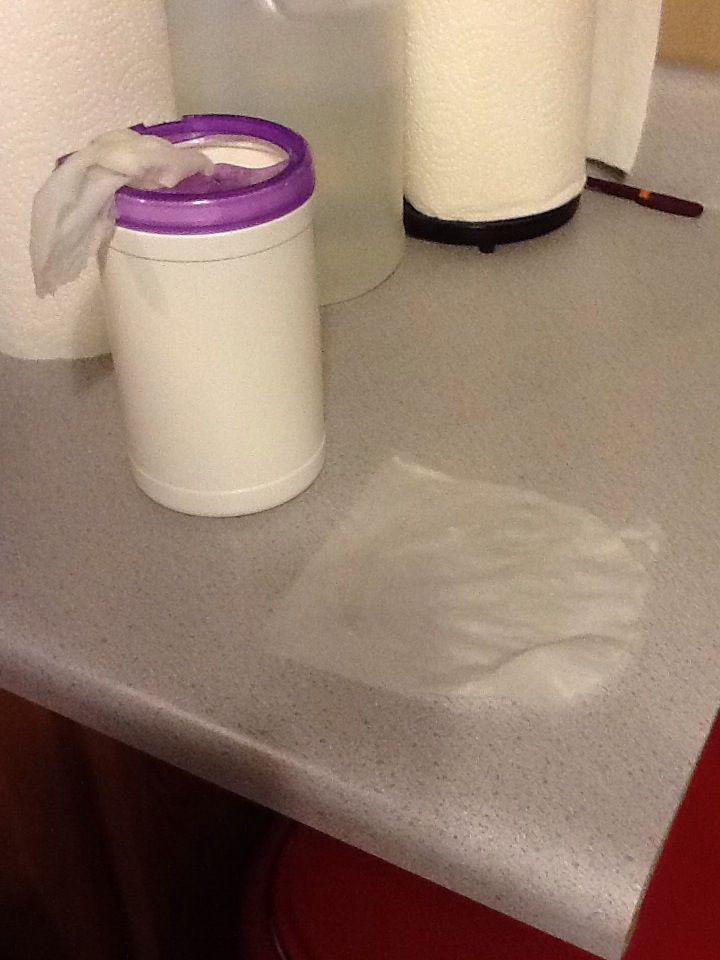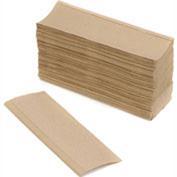The first image is the image on the left, the second image is the image on the right. Evaluate the accuracy of this statement regarding the images: "One of the images shows brown folded paper towels.". Is it true? Answer yes or no. Yes. The first image is the image on the left, the second image is the image on the right. Assess this claim about the two images: "Each roll of paper towel is on a roller.". Correct or not? Answer yes or no. No. 